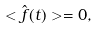<formula> <loc_0><loc_0><loc_500><loc_500>< \hat { f } ( t ) > = 0 ,</formula> 